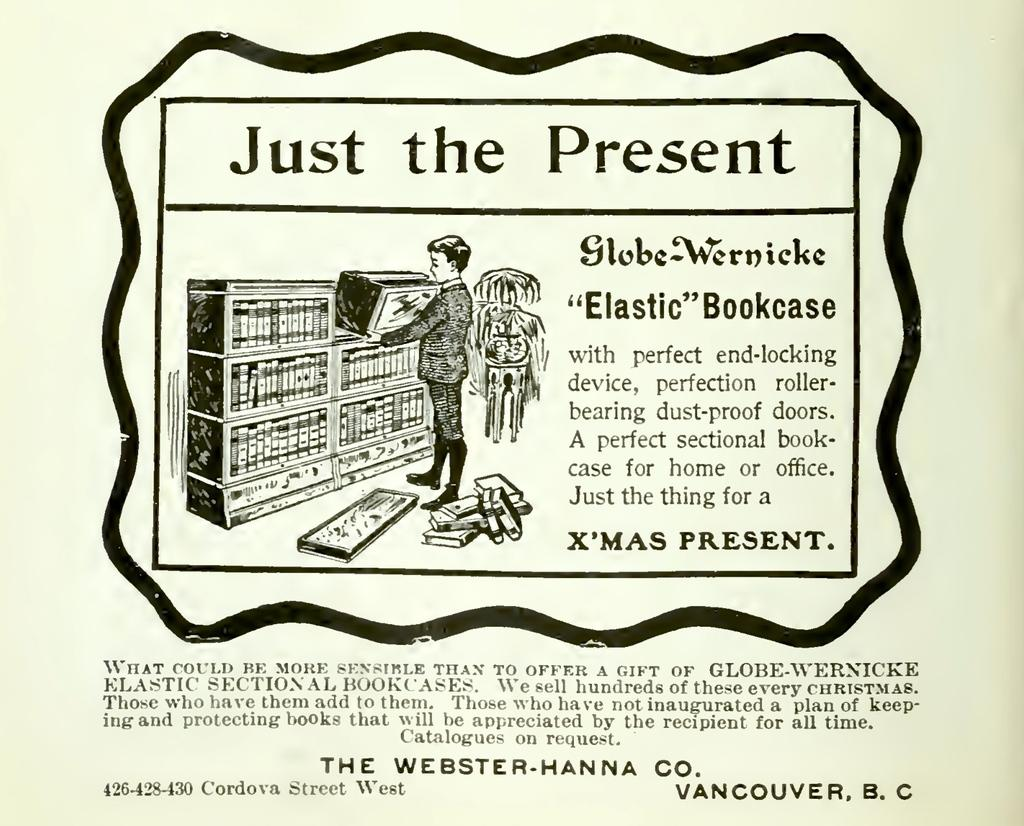What is the main subject of the image? There is a person standing in the image. What is the person holding in his hand? The person is holding a box in his hand. Can you describe any additional objects or elements in the image? There is writing or matter on a paper in the image. What is the color scheme of the image? The image is in black and white color. What type of cork can be seen in the image? There is no cork present in the image. Is the army visible in the image? There is no reference to an army or any military elements in the image. 